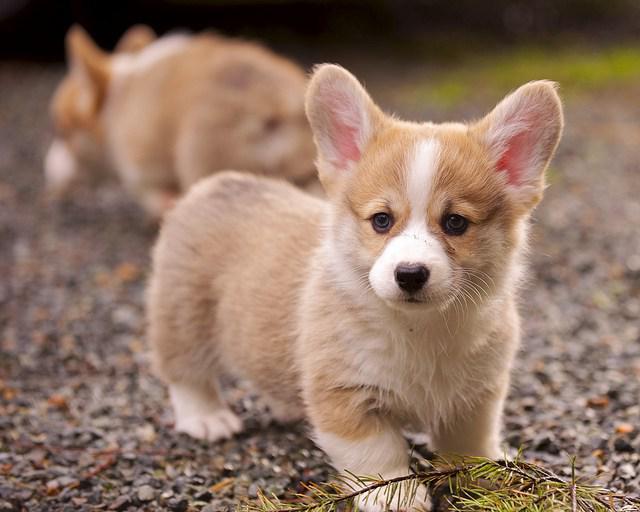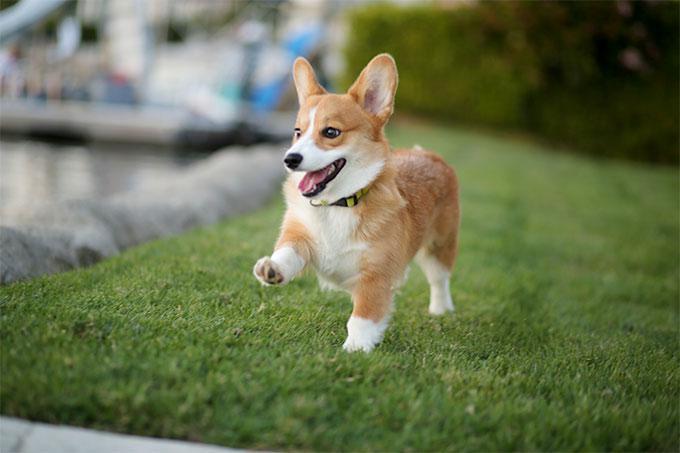The first image is the image on the left, the second image is the image on the right. Given the left and right images, does the statement "the tongue is out on the dogs wide open mouth" hold true? Answer yes or no. Yes. 